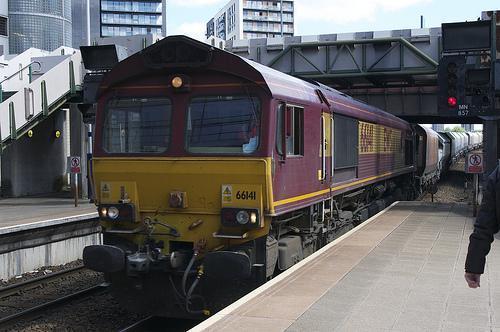How many trains?
Give a very brief answer. 1. How many airplanes are on the track?
Give a very brief answer. 0. 